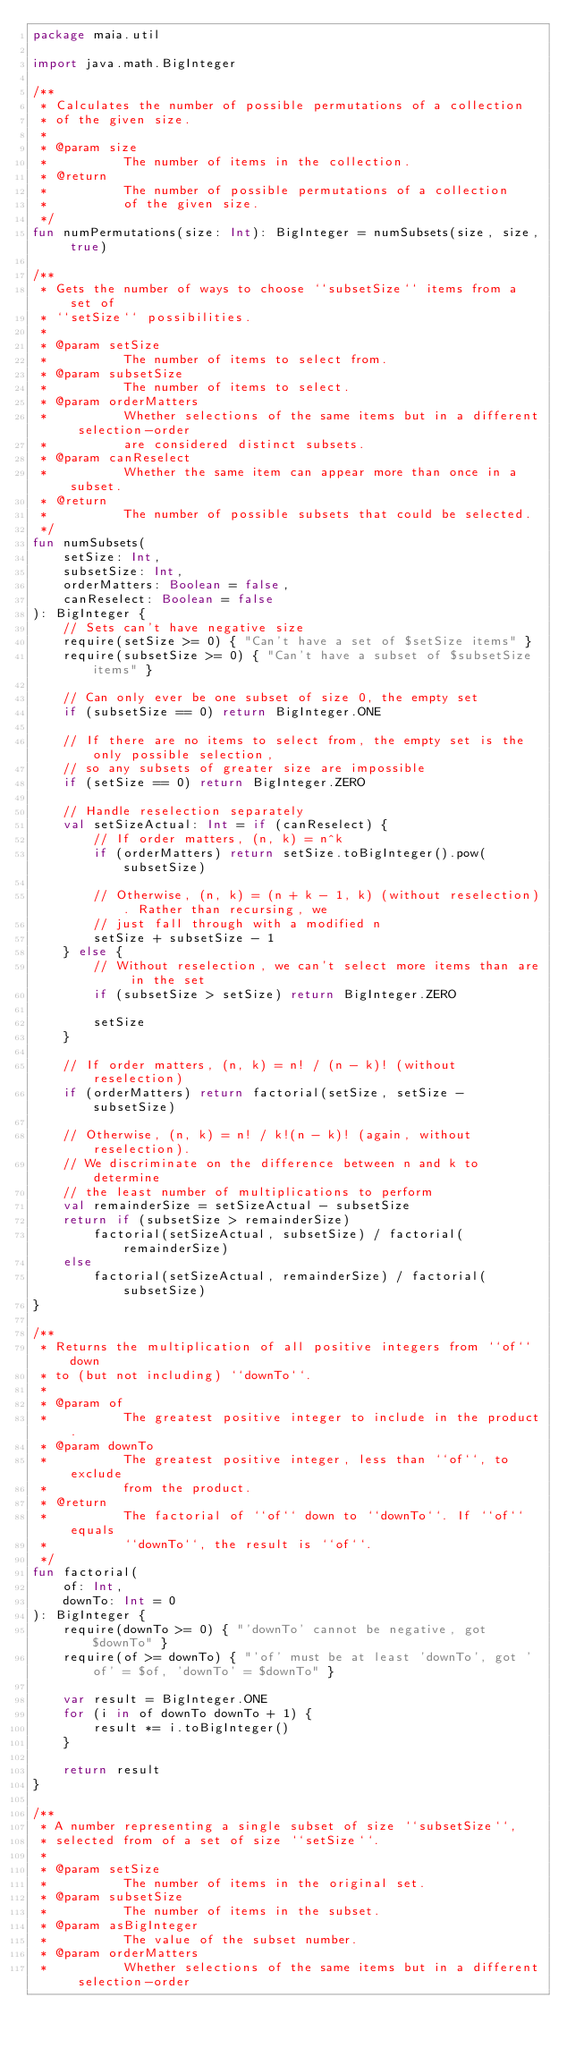Convert code to text. <code><loc_0><loc_0><loc_500><loc_500><_Kotlin_>package maia.util

import java.math.BigInteger

/**
 * Calculates the number of possible permutations of a collection
 * of the given size.
 *
 * @param size
 *          The number of items in the collection.
 * @return
 *          The number of possible permutations of a collection
 *          of the given size.
 */
fun numPermutations(size: Int): BigInteger = numSubsets(size, size, true)

/**
 * Gets the number of ways to choose ``subsetSize`` items from a set of
 * ``setSize`` possibilities.
 *
 * @param setSize
 *          The number of items to select from.
 * @param subsetSize
 *          The number of items to select.
 * @param orderMatters
 *          Whether selections of the same items but in a different selection-order
 *          are considered distinct subsets.
 * @param canReselect
 *          Whether the same item can appear more than once in a subset.
 * @return
 *          The number of possible subsets that could be selected.
 */
fun numSubsets(
    setSize: Int,
    subsetSize: Int,
    orderMatters: Boolean = false,
    canReselect: Boolean = false
): BigInteger {
    // Sets can't have negative size
    require(setSize >= 0) { "Can't have a set of $setSize items" }
    require(subsetSize >= 0) { "Can't have a subset of $subsetSize items" }

    // Can only ever be one subset of size 0, the empty set
    if (subsetSize == 0) return BigInteger.ONE

    // If there are no items to select from, the empty set is the only possible selection,
    // so any subsets of greater size are impossible
    if (setSize == 0) return BigInteger.ZERO

    // Handle reselection separately
    val setSizeActual: Int = if (canReselect) {
        // If order matters, (n, k) = n^k
        if (orderMatters) return setSize.toBigInteger().pow(subsetSize)

        // Otherwise, (n, k) = (n + k - 1, k) (without reselection). Rather than recursing, we
        // just fall through with a modified n
        setSize + subsetSize - 1
    } else {
        // Without reselection, we can't select more items than are in the set
        if (subsetSize > setSize) return BigInteger.ZERO

        setSize
    }

    // If order matters, (n, k) = n! / (n - k)! (without reselection)
    if (orderMatters) return factorial(setSize, setSize - subsetSize)

    // Otherwise, (n, k) = n! / k!(n - k)! (again, without reselection).
    // We discriminate on the difference between n and k to determine
    // the least number of multiplications to perform
    val remainderSize = setSizeActual - subsetSize
    return if (subsetSize > remainderSize)
        factorial(setSizeActual, subsetSize) / factorial(remainderSize)
    else
        factorial(setSizeActual, remainderSize) / factorial(subsetSize)
}

/**
 * Returns the multiplication of all positive integers from ``of`` down
 * to (but not including) ``downTo``.
 *
 * @param of
 *          The greatest positive integer to include in the product.
 * @param downTo
 *          The greatest positive integer, less than ``of``, to exclude
 *          from the product.
 * @return
 *          The factorial of ``of`` down to ``downTo``. If ``of`` equals
 *          ``downTo``, the result is ``of``.
 */
fun factorial(
    of: Int,
    downTo: Int = 0
): BigInteger {
    require(downTo >= 0) { "'downTo' cannot be negative, got $downTo" }
    require(of >= downTo) { "'of' must be at least 'downTo', got 'of' = $of, 'downTo' = $downTo" }

    var result = BigInteger.ONE
    for (i in of downTo downTo + 1) {
        result *= i.toBigInteger()
    }

    return result
}

/**
 * A number representing a single subset of size ``subsetSize``,
 * selected from of a set of size ``setSize``.
 *
 * @param setSize
 *          The number of items in the original set.
 * @param subsetSize
 *          The number of items in the subset.
 * @param asBigInteger
 *          The value of the subset number.
 * @param orderMatters
 *          Whether selections of the same items but in a different selection-order</code> 